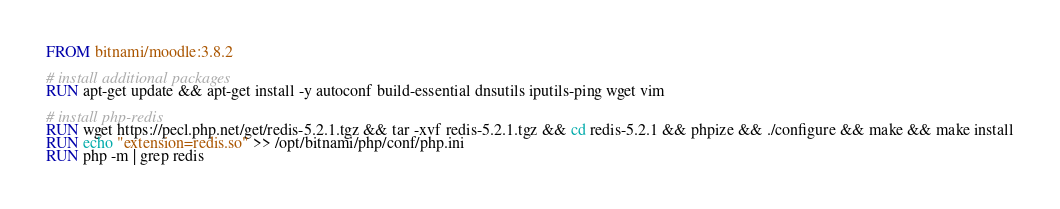<code> <loc_0><loc_0><loc_500><loc_500><_Dockerfile_>FROM bitnami/moodle:3.8.2

# install additional packages
RUN apt-get update && apt-get install -y autoconf build-essential dnsutils iputils-ping wget vim

# install php-redis
RUN wget https://pecl.php.net/get/redis-5.2.1.tgz && tar -xvf redis-5.2.1.tgz && cd redis-5.2.1 && phpize && ./configure && make && make install
RUN echo "extension=redis.so" >> /opt/bitnami/php/conf/php.ini
RUN php -m | grep redis</code> 